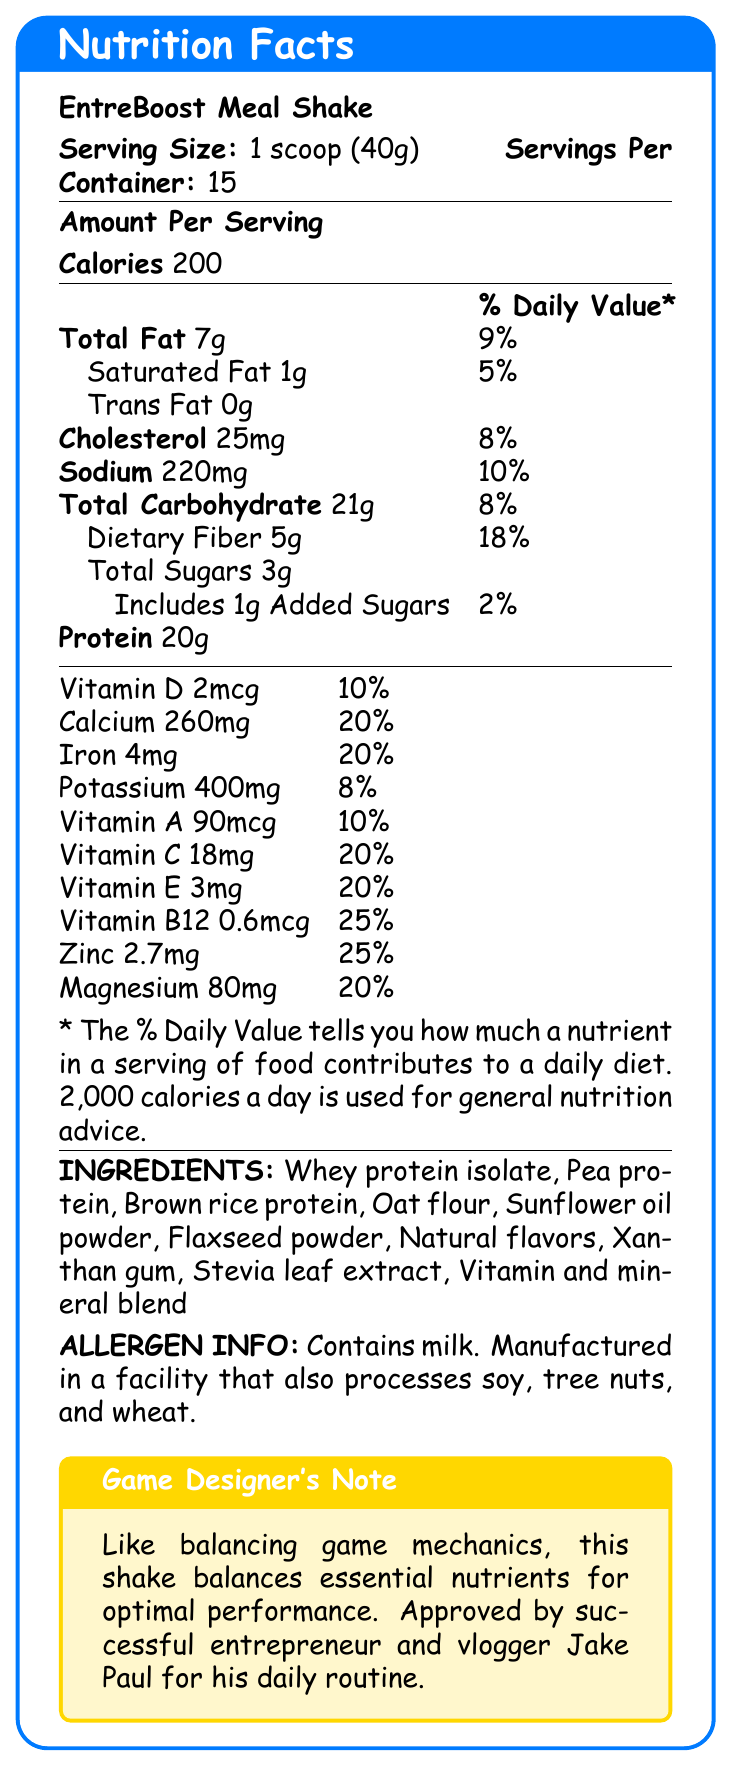what is the serving size of EntreBoost Meal Shake? The serving size is mentioned at the top of the Nutrition Facts label.
Answer: 1 scoop (40g) how many calories are in each serving of the shake? The calories per serving are listed in the Amount Per Serving section.
Answer: 200 how much protein is in one serving of the shake? Protein content is stated in the Amount Per Serving section.
Answer: 20g what percentage of Dietary Fiber does one serving provide? The % Daily Value for Dietary Fiber is provided in the Total Carbohydrate subsection.
Answer: 18% which vitamin has the highest daily value percentage in the shake? Vitamin B12 has the highest daily value percentage at 25%.
Answer: Vitamin B12 how many servings are there per container? The number of servings per container is listed at the top of the Nutrition Facts label next to the serving size.
Answer: 15 does this shake contain any trans fat? It specifies 0g Trans Fat in the Total Fat subsection.
Answer: No which of the following nutrients is not included in the shake? A. Vitamin K B. Calcium C. Iron D. Vitamin E Vitamin K is not listed in the vitamins and minerals section of the label, unlike the other options.
Answer: A. Vitamin K what is the total amount of sugars in one serving? The total amount of sugars is located in the Total Sugars section.
Answer: 3g how much Sodium does one serving contain? Sodium content is listed in the Amount Per Serving section.
Answer: 220mg does the shake contain any allergens? The Allergen Info section mentions that it contains milk and is manufactured in a facility that processes soy, tree nuts, and wheat.
Answer: Yes which marketing claim is not made for the shake? A. Supports cognitive function and sustained energy B. Contains artificial colors and preservatives C. Designed for busy entrepreneurs and go-getters D. Rich in fiber for digestive health The marketing claims section states that the shake contains no artificial colors or preservatives.
Answer: B. Contains artificial colors and preservatives is this shake approved by Jake Paul? The Game Designer’s Note mentions that the shake is approved by successful entrepreneur and vlogger Jake Paul.
Answer: Yes summarize the main idea of the document. The document is a formatted Nutrition Facts label for EntreBoost Meal Shake, displaying comprehensive nutritional content, marketing claims, and endorsements for potential consumers.
Answer: The document provides detailed nutritional information about the EntreBoost Meal Shake, designed for aspiring entrepreneurs. It highlights key nutrients, vitamins, ingredients, and allergen information. The shake is marketed as a convenient meal replacement that supports cognitive function and sustained energy, contains no artificial colors or preservatives, and is endorsed by Jake Paul. what is the main protein source in the shake? The document lists multiple protein sources (Whey protein isolate, Pea protein, Brown rice protein) without indicating which is the main one.
Answer: Cannot be determined 